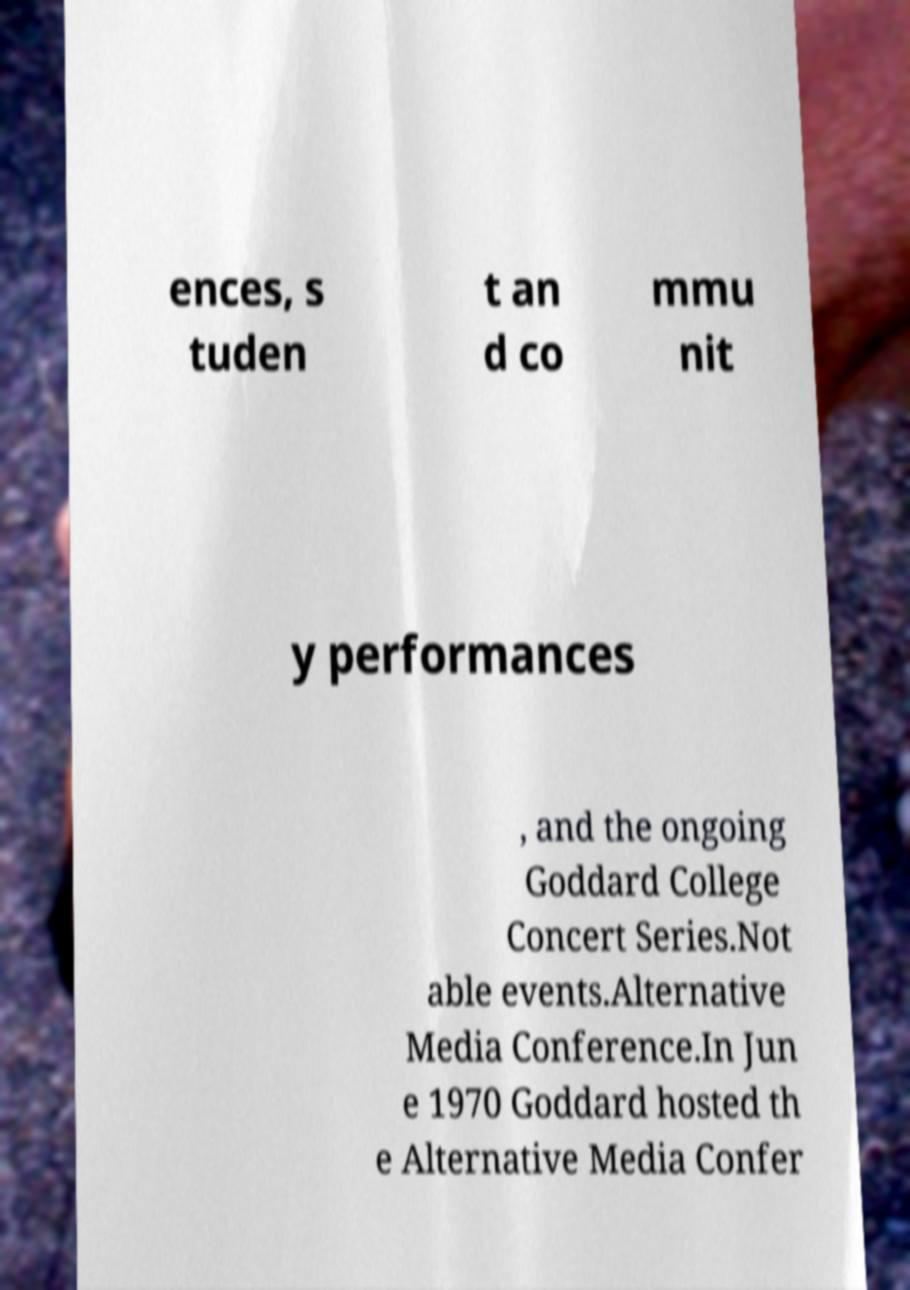Could you assist in decoding the text presented in this image and type it out clearly? ences, s tuden t an d co mmu nit y performances , and the ongoing Goddard College Concert Series.Not able events.Alternative Media Conference.In Jun e 1970 Goddard hosted th e Alternative Media Confer 